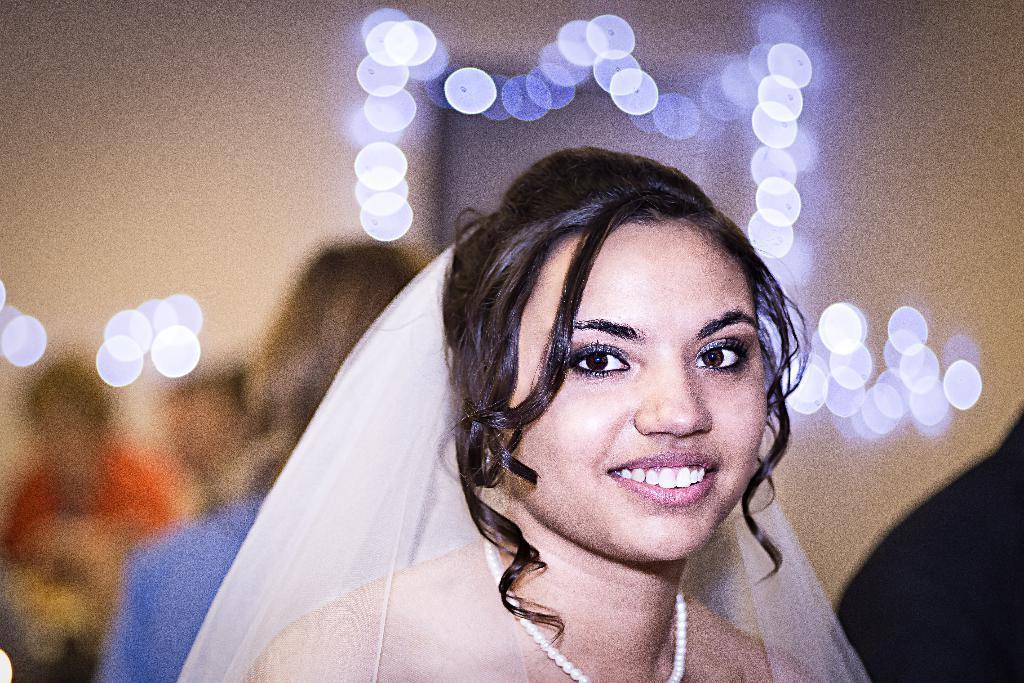How would you summarize this image in a sentence or two? In this image, we can see a woman, she is smiling, there is a blur background, there are some people in the background and we can see lights. 